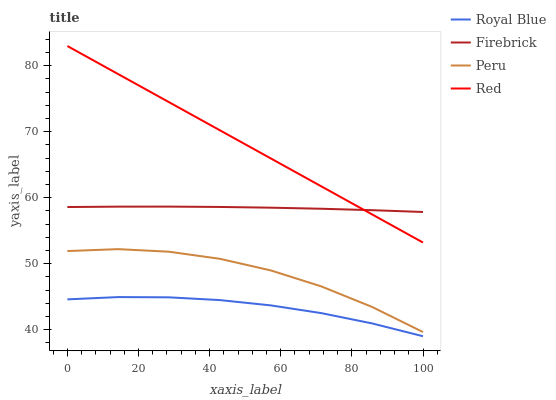Does Royal Blue have the minimum area under the curve?
Answer yes or no. Yes. Does Red have the maximum area under the curve?
Answer yes or no. Yes. Does Firebrick have the minimum area under the curve?
Answer yes or no. No. Does Firebrick have the maximum area under the curve?
Answer yes or no. No. Is Red the smoothest?
Answer yes or no. Yes. Is Peru the roughest?
Answer yes or no. Yes. Is Firebrick the smoothest?
Answer yes or no. No. Is Firebrick the roughest?
Answer yes or no. No. Does Red have the lowest value?
Answer yes or no. No. Does Red have the highest value?
Answer yes or no. Yes. Does Firebrick have the highest value?
Answer yes or no. No. Is Peru less than Red?
Answer yes or no. Yes. Is Firebrick greater than Peru?
Answer yes or no. Yes. Does Firebrick intersect Red?
Answer yes or no. Yes. Is Firebrick less than Red?
Answer yes or no. No. Is Firebrick greater than Red?
Answer yes or no. No. Does Peru intersect Red?
Answer yes or no. No. 